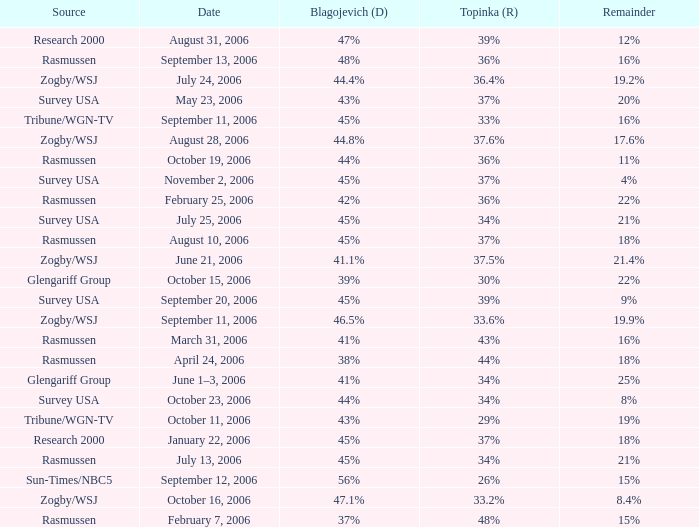Which Blagojevich (D) has a Source of zogby/wsj, and a Topinka (R) of 33.2%? 47.1%. 